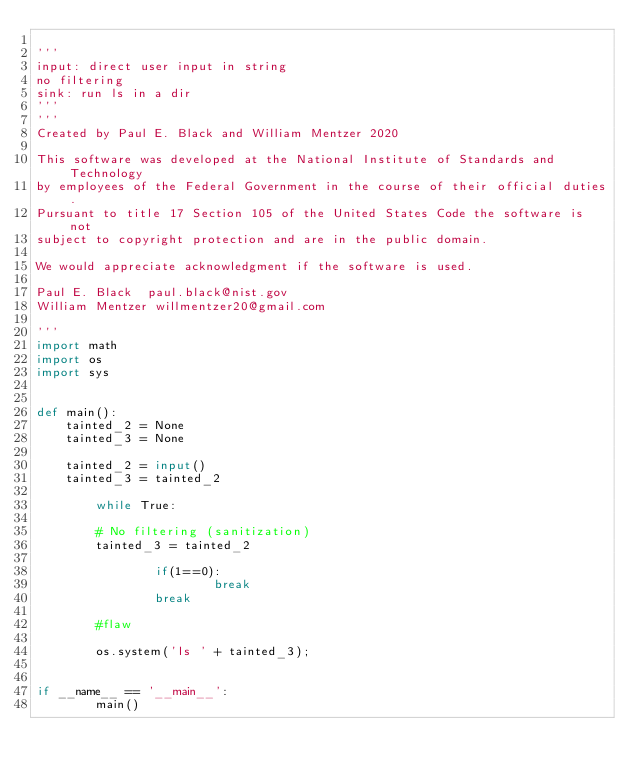Convert code to text. <code><loc_0><loc_0><loc_500><loc_500><_Python_>
'''
input: direct user input in string
no filtering
sink: run ls in a dir
'''
'''
Created by Paul E. Black and William Mentzer 2020

This software was developed at the National Institute of Standards and Technology
by employees of the Federal Government in the course of their official duties.
Pursuant to title 17 Section 105 of the United States Code the software is not
subject to copyright protection and are in the public domain.

We would appreciate acknowledgment if the software is used.

Paul E. Black  paul.black@nist.gov
William Mentzer willmentzer20@gmail.com

'''
import math
import os
import sys


def main():
    tainted_2 = None
    tainted_3 = None

    tainted_2 = input()
    tainted_3 = tainted_2

        while True:
                
        # No filtering (sanitization)
        tainted_3 = tainted_2
            
                if(1==0):
                        break
                break

        #flaw

        os.system('ls ' + tainted_3);
            

if __name__ == '__main__':
        main()</code> 